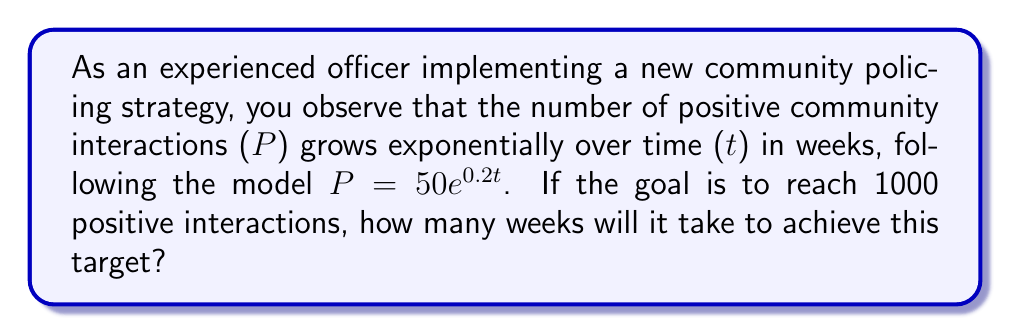Help me with this question. To solve this problem, we'll use the given exponential growth model and follow these steps:

1) The model is given by $P = 50e^{0.2t}$, where P is the number of positive interactions and t is time in weeks.

2) We want to find t when P = 1000. So, we set up the equation:

   $1000 = 50e^{0.2t}$

3) Divide both sides by 50:

   $20 = e^{0.2t}$

4) Take the natural logarithm of both sides:

   $\ln(20) = \ln(e^{0.2t})$

5) Simplify the right side using the property of logarithms:

   $\ln(20) = 0.2t$

6) Divide both sides by 0.2:

   $\frac{\ln(20)}{0.2} = t$

7) Calculate the result:

   $t \approx 14.98$ weeks

8) Since we can't have a fraction of a week in this context, we round up to the nearest whole number:

   $t = 15$ weeks
Answer: 15 weeks 